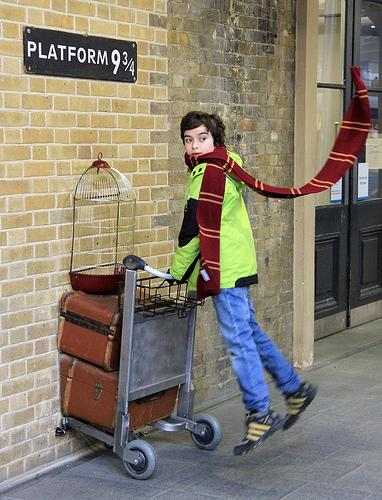Point out the boy's actions and his outfit in the image. The boy is in mid-air, wearing a vibrant green jacket, blue jeans, a striped scarf, and a pair of shoes. Describe the most noticeable attributes of the boy in the image. The boy is airborne, donning a bright green jacket, blue jeans, a long maroon scarf, and jumping shoes. State the primary subject in the image, and describe their attire and actions. The central figure is a boy who appears to be flying, dressed in a green jacket, blue jeans, a maroon scarf, and shoes. Explain what the boy is doing, and describe the color and style of his clothing. The boy in the picture is floating, attired in a neon green jacket, blue jeans, shoes, and a striped maroon scarf. Briefly describe the scene presented in the image. A boy wearing a green jacket, blue jeans, and a scarf is floating in the air near a brick wall, with suitcases and a bird cage on a two-wheeled cart. Summarize the content of the image in one sentence. A boy in colorful attire jumps near a brick wall, as luggage and a bird cage rest on a nearby cart. Narrate what the boy appears to be doing in the image, and mention his clothing. The boy is seemingly levitating, clad in a neon green jacket, blue jeans, a maroon scarf, and shoes. Explain the action happening in the image and the objects involved. A boy seems to be entering a brick wall, while wearing a scarf and accompanied by a cart carrying suitcases and a bird cage. State what the boy in the image is doing and what he's wearing. The boy is floating in the air, while wearing a neon green jacket, blue jeans, shoes, and a striped maroon scarf. Provide a brief summary of the key elements in the image. Floating boy in bright attire, brick wall, two-wheeled cart with luggage and bird cage. 